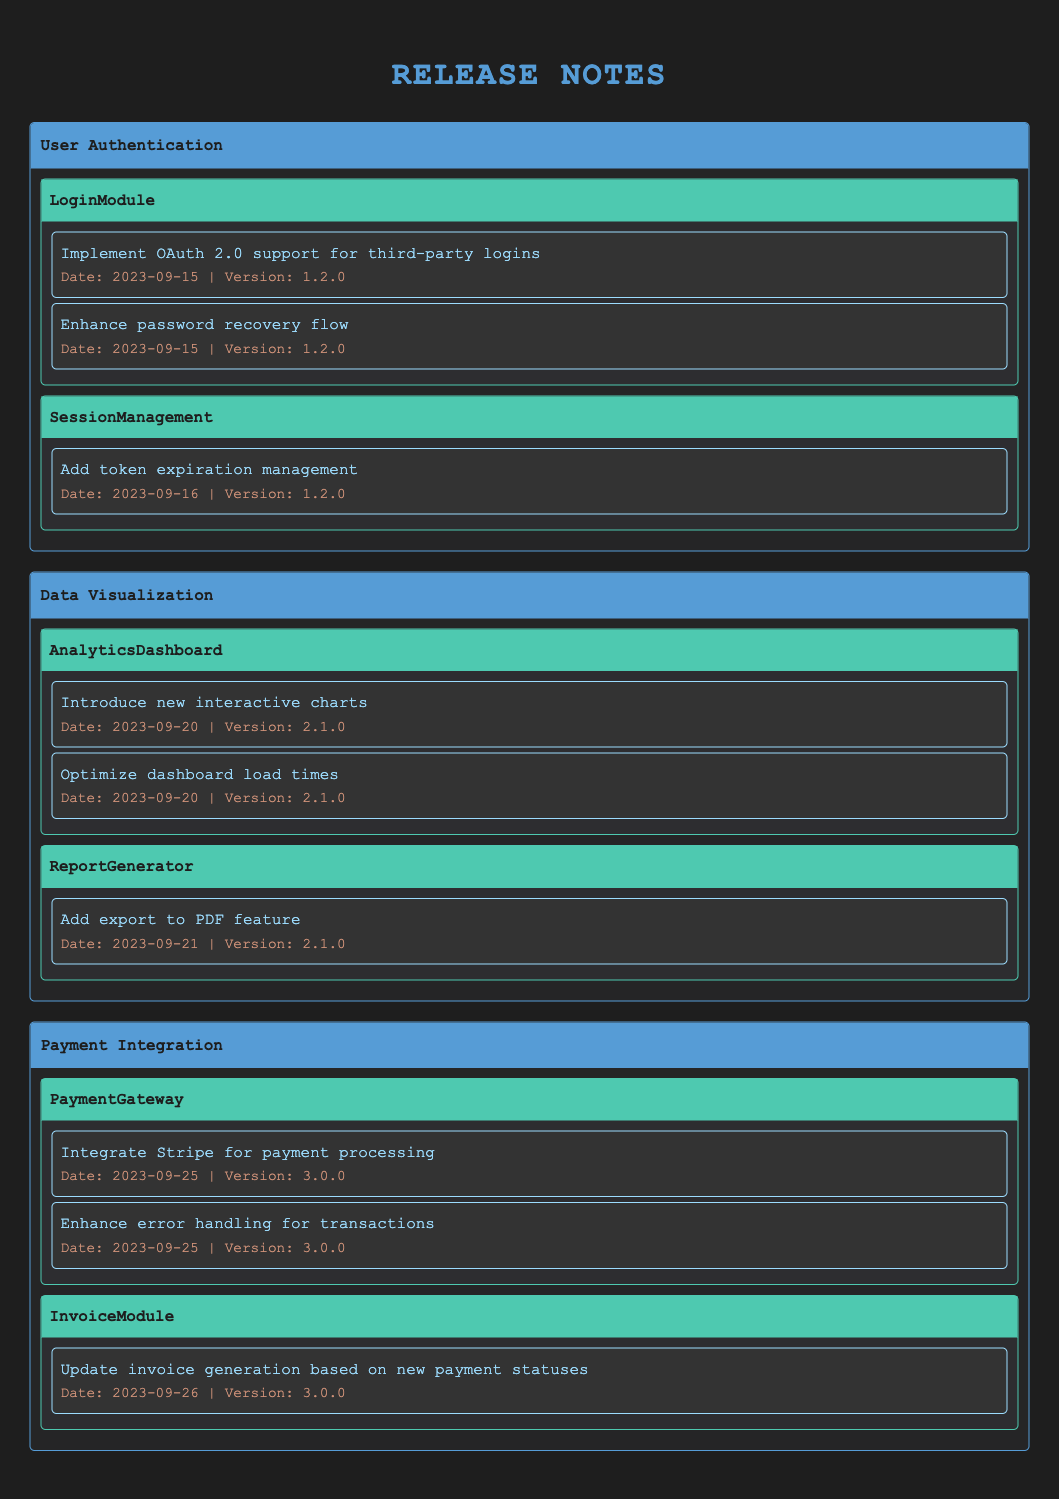What is the latest version of the User Authentication feature set? The User Authentication feature set has two impacted modules. Both modules list changes under version 1.2.0. This is the highest version number associated with the feature set.
Answer: 1.2.0 How many changes were made to the PaymentGateway module? The table lists two changes under the PaymentGateway module, specifically "Integrate Stripe for payment processing" and "Enhance error handling for transactions."
Answer: 2 Which module had changes made on September 20, 2023? Referring to the table, the AnalyticsDashboard module lists two changes made on that date: "Introduce new interactive charts" and "Optimize dashboard load times." Thus, AnalyticsDashboard had changes on September 20, 2023.
Answer: AnalyticsDashboard Did the InvoiceModule have any changes related to payment statuses? The InvoiceModule shows one change: "Update invoice generation based on new payment statuses," which confirms that it did have changes related to payment statuses.
Answer: Yes Which feature set has the most modules impacted based on the table? Reviewing the feature sets, User Authentication has two impacted modules (LoginModule and SessionManagement), Data Visualization also has two (AnalyticsDashboard and ReportGenerator), and Payment Integration has two (PaymentGateway and InvoiceModule). Therefore, all feature sets have an equal number of impacted modules.
Answer: None (all have equal) What is the date of the earliest change listed in the table? Scanning through the changes in the modules, the earliest date recorded is September 15, 2023, for the User Authentication feature set's LoginModule.
Answer: September 15, 2023 How many total changes were listed across all feature sets? By counting the changes listed under each impacted module across all feature sets, there are 8 changes in total: 2 from User Authentication, 3 from Data Visualization, and 3 from Payment Integration.
Answer: 8 If we look for enhancements related to chart functionalities, how many are present? In the Data Visualization feature set, specifically within the AnalyticsDashboard module, there is a change "Introduce new interactive charts," indicating one enhancement related to chart functionalities.
Answer: 1 Which impacted module had the most recent change as of the data provided? The most recent change is from the InvoiceModule under the Payment Integration feature set, dated September 26, 2023. This is the latest date mentioned in all changes.
Answer: InvoiceModule 